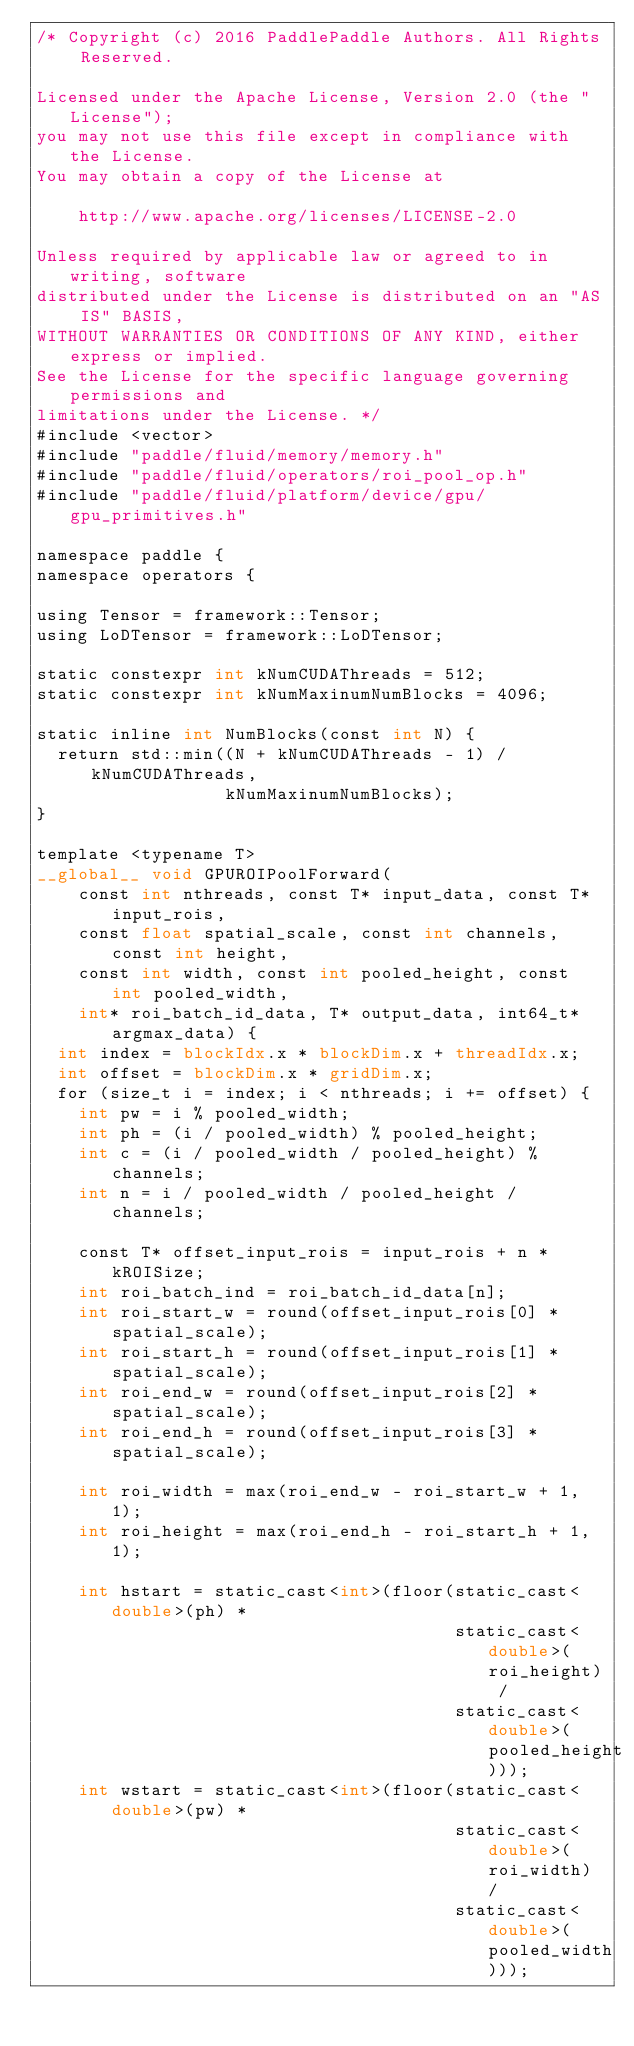<code> <loc_0><loc_0><loc_500><loc_500><_Cuda_>/* Copyright (c) 2016 PaddlePaddle Authors. All Rights Reserved.

Licensed under the Apache License, Version 2.0 (the "License");
you may not use this file except in compliance with the License.
You may obtain a copy of the License at

    http://www.apache.org/licenses/LICENSE-2.0

Unless required by applicable law or agreed to in writing, software
distributed under the License is distributed on an "AS IS" BASIS,
WITHOUT WARRANTIES OR CONDITIONS OF ANY KIND, either express or implied.
See the License for the specific language governing permissions and
limitations under the License. */
#include <vector>
#include "paddle/fluid/memory/memory.h"
#include "paddle/fluid/operators/roi_pool_op.h"
#include "paddle/fluid/platform/device/gpu/gpu_primitives.h"

namespace paddle {
namespace operators {

using Tensor = framework::Tensor;
using LoDTensor = framework::LoDTensor;

static constexpr int kNumCUDAThreads = 512;
static constexpr int kNumMaxinumNumBlocks = 4096;

static inline int NumBlocks(const int N) {
  return std::min((N + kNumCUDAThreads - 1) / kNumCUDAThreads,
                  kNumMaxinumNumBlocks);
}

template <typename T>
__global__ void GPUROIPoolForward(
    const int nthreads, const T* input_data, const T* input_rois,
    const float spatial_scale, const int channels, const int height,
    const int width, const int pooled_height, const int pooled_width,
    int* roi_batch_id_data, T* output_data, int64_t* argmax_data) {
  int index = blockIdx.x * blockDim.x + threadIdx.x;
  int offset = blockDim.x * gridDim.x;
  for (size_t i = index; i < nthreads; i += offset) {
    int pw = i % pooled_width;
    int ph = (i / pooled_width) % pooled_height;
    int c = (i / pooled_width / pooled_height) % channels;
    int n = i / pooled_width / pooled_height / channels;

    const T* offset_input_rois = input_rois + n * kROISize;
    int roi_batch_ind = roi_batch_id_data[n];
    int roi_start_w = round(offset_input_rois[0] * spatial_scale);
    int roi_start_h = round(offset_input_rois[1] * spatial_scale);
    int roi_end_w = round(offset_input_rois[2] * spatial_scale);
    int roi_end_h = round(offset_input_rois[3] * spatial_scale);

    int roi_width = max(roi_end_w - roi_start_w + 1, 1);
    int roi_height = max(roi_end_h - roi_start_h + 1, 1);

    int hstart = static_cast<int>(floor(static_cast<double>(ph) *
                                        static_cast<double>(roi_height) /
                                        static_cast<double>(pooled_height)));
    int wstart = static_cast<int>(floor(static_cast<double>(pw) *
                                        static_cast<double>(roi_width) /
                                        static_cast<double>(pooled_width)));</code> 